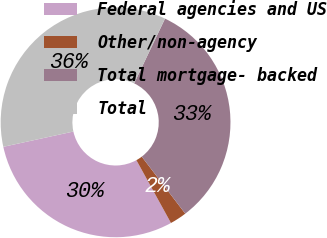<chart> <loc_0><loc_0><loc_500><loc_500><pie_chart><fcel>Federal agencies and US<fcel>Other/non-agency<fcel>Total mortgage- backed<fcel>Total<nl><fcel>29.59%<fcel>2.37%<fcel>32.54%<fcel>35.5%<nl></chart> 